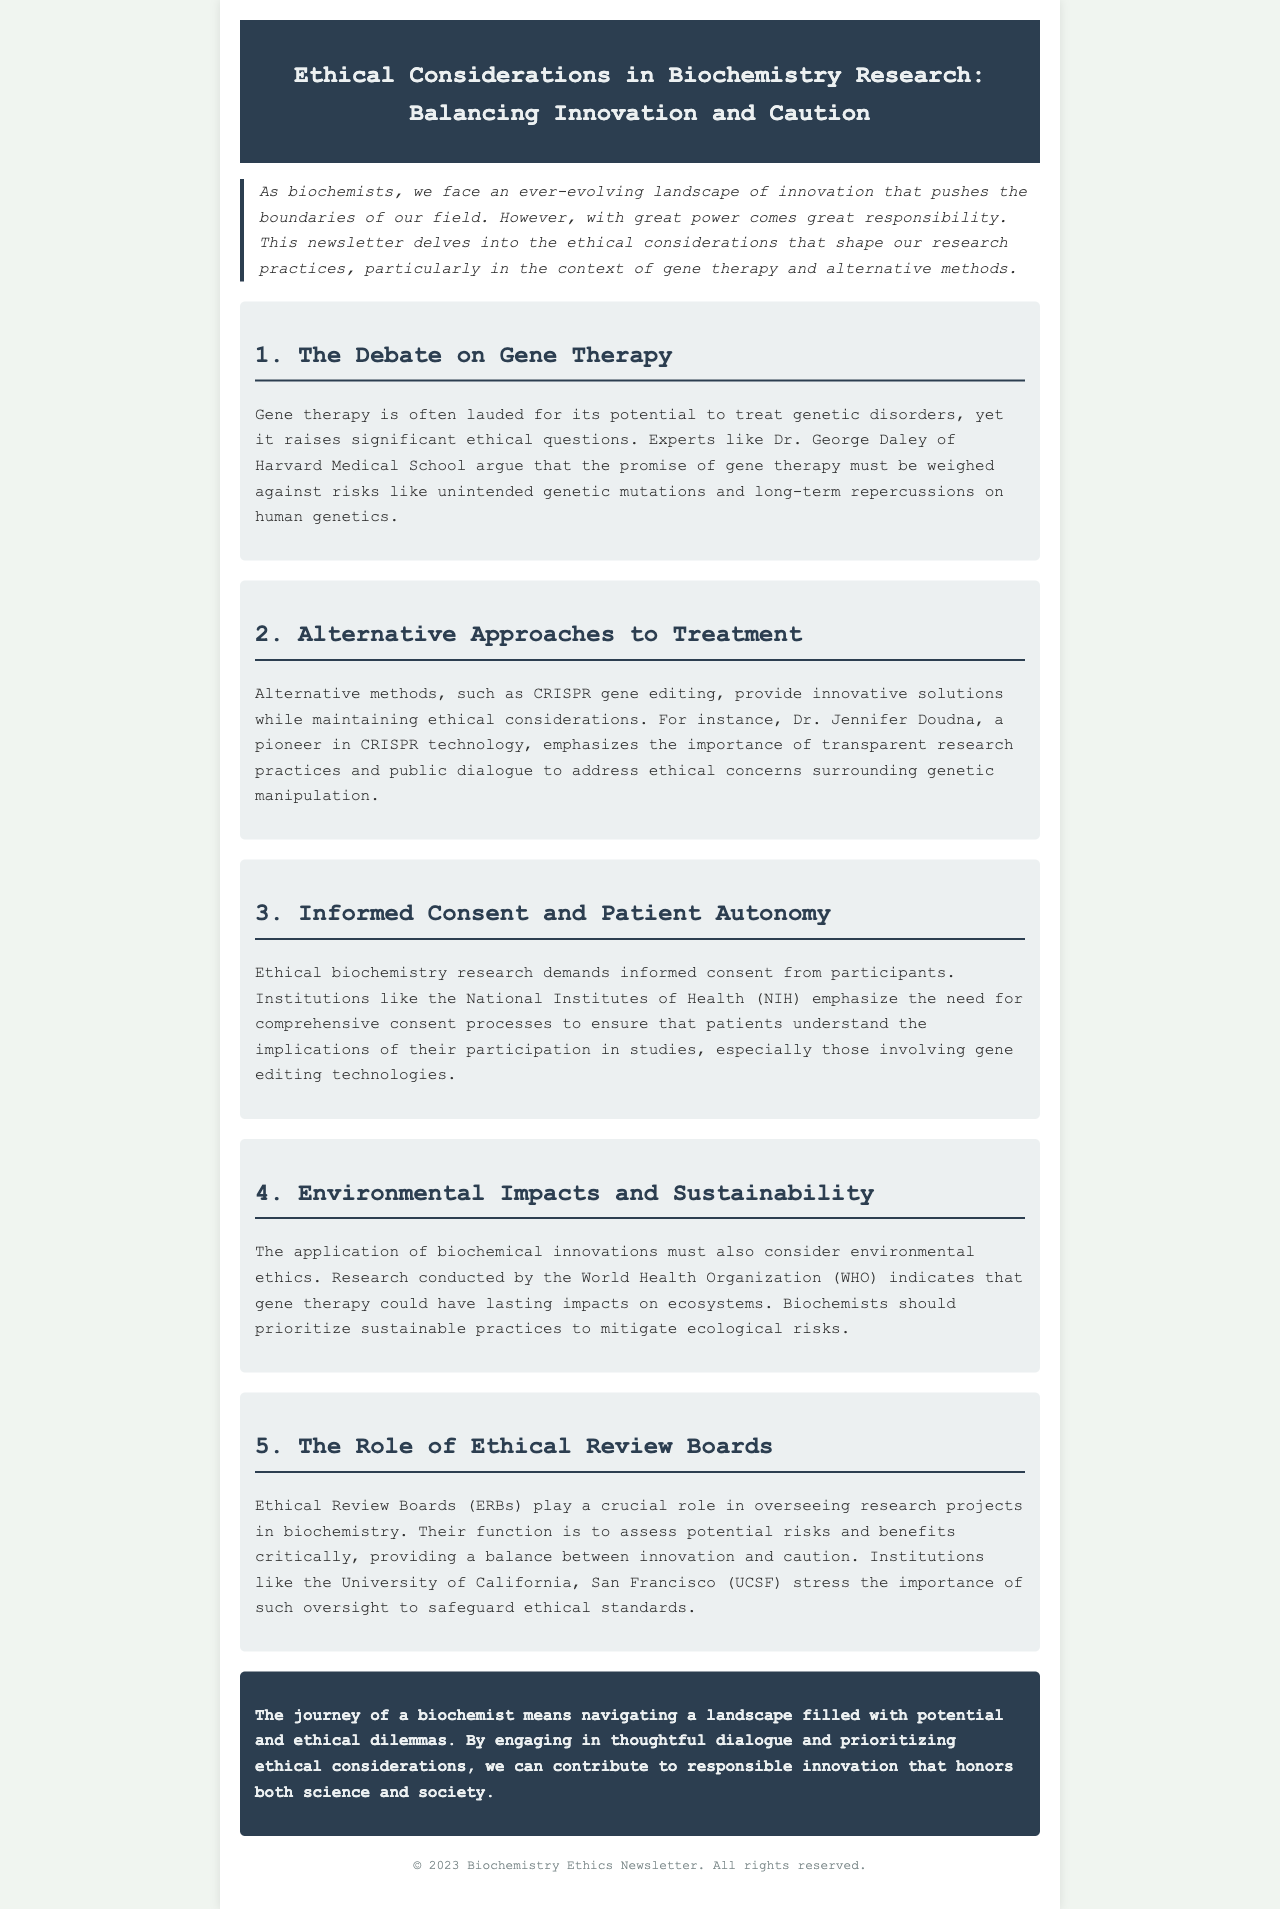What is the title of the newsletter? The title of the newsletter is explicitly mentioned in the header section of the document.
Answer: Ethical Considerations in Biochemistry Research: Balancing Innovation and Caution Who is mentioned as a pioneer in CRISPR technology? The document provides the name of a significant figure related to CRISPR technology in the section about Alternative Approaches to Treatment.
Answer: Dr. Jennifer Doudna Which organization emphasizes the need for informed consent processes? The institution that stresses the necessity for informed consent is identified in the section regarding informed consent and patient autonomy.
Answer: National Institutes of Health (NIH) What is one potential risk associated with gene therapy? The section on the Debate on Gene Therapy outlines risks connected to gene therapy, focusing on one specific concern.
Answer: Unintended genetic mutations What role do Ethical Review Boards (ERBs) have in biochemistry research? The document describes the responsibility of ERBs, which is mentioned in the section dedicated to their role.
Answer: Overseeing research projects What aspect does the World Health Organization (WHO) highlight regarding gene therapy? In the section about Environmental Impacts and Sustainability, the document mentions a focus of the WHO related to gene therapy.
Answer: Lasting impacts on ecosystems What is emphasized as important in addressing ethical concerns surrounding genetic manipulation? The document highlights the necessity of a particular practice in the section about Alternative Approaches to Treatment.
Answer: Transparent research practices Which university is mentioned for stressing the importance of ethical oversight? The university noted for its emphasis on ethical standards in research is mentioned in the section about the Role of Ethical Review Boards.
Answer: University of California, San Francisco (UCSF) 